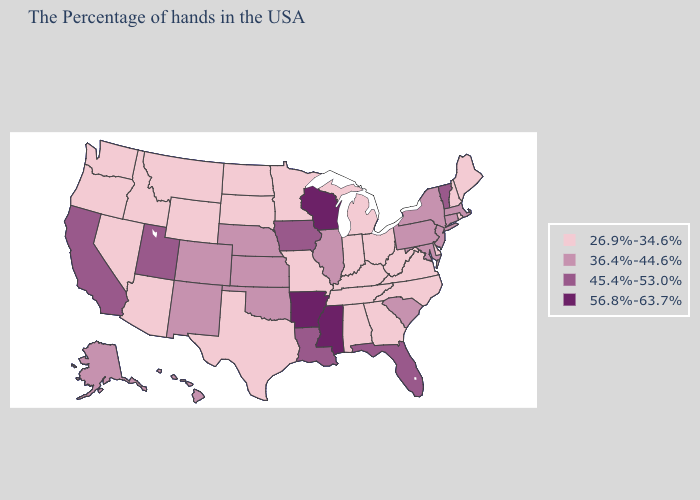Name the states that have a value in the range 36.4%-44.6%?
Be succinct. Massachusetts, Connecticut, New York, New Jersey, Maryland, Pennsylvania, South Carolina, Illinois, Kansas, Nebraska, Oklahoma, Colorado, New Mexico, Alaska, Hawaii. Name the states that have a value in the range 56.8%-63.7%?
Be succinct. Wisconsin, Mississippi, Arkansas. What is the value of Missouri?
Keep it brief. 26.9%-34.6%. Does California have the lowest value in the West?
Give a very brief answer. No. Does the map have missing data?
Give a very brief answer. No. Which states hav the highest value in the West?
Be succinct. Utah, California. Is the legend a continuous bar?
Keep it brief. No. What is the highest value in the USA?
Concise answer only. 56.8%-63.7%. What is the value of Arizona?
Keep it brief. 26.9%-34.6%. What is the highest value in states that border Mississippi?
Answer briefly. 56.8%-63.7%. What is the lowest value in the South?
Concise answer only. 26.9%-34.6%. Name the states that have a value in the range 45.4%-53.0%?
Give a very brief answer. Vermont, Florida, Louisiana, Iowa, Utah, California. Does Oregon have a higher value than California?
Quick response, please. No. What is the value of Hawaii?
Be succinct. 36.4%-44.6%. 